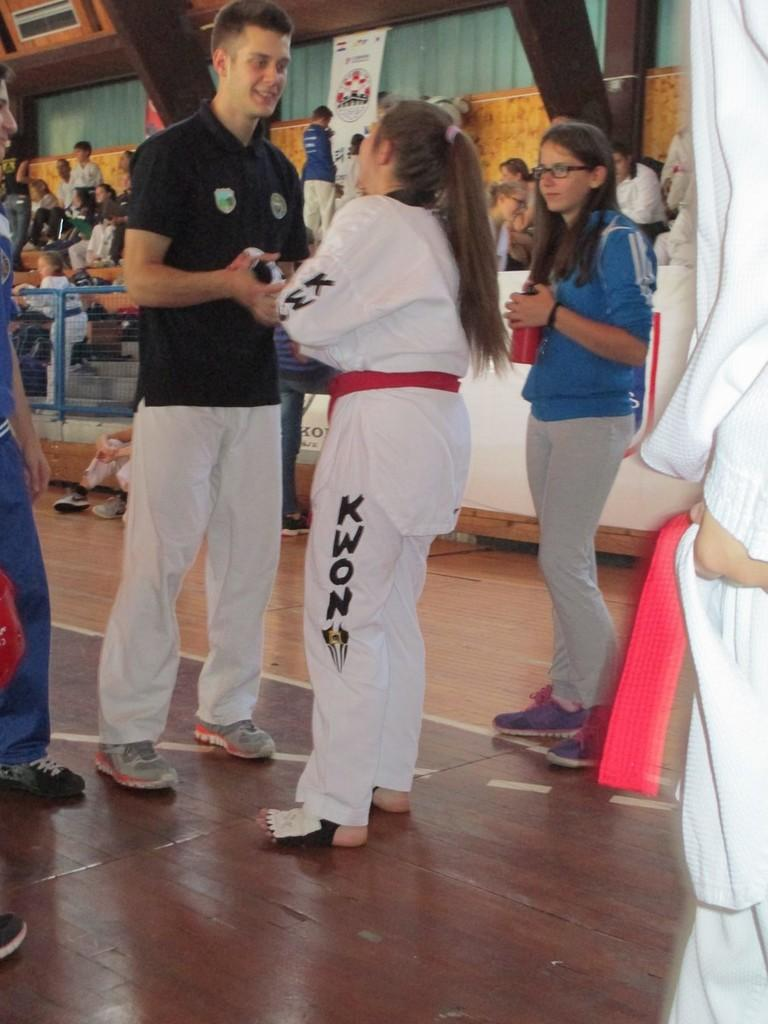<image>
Describe the image concisely. A  martial arts student  with a logo  KWON on her pants leg.with a male talking on the floor 